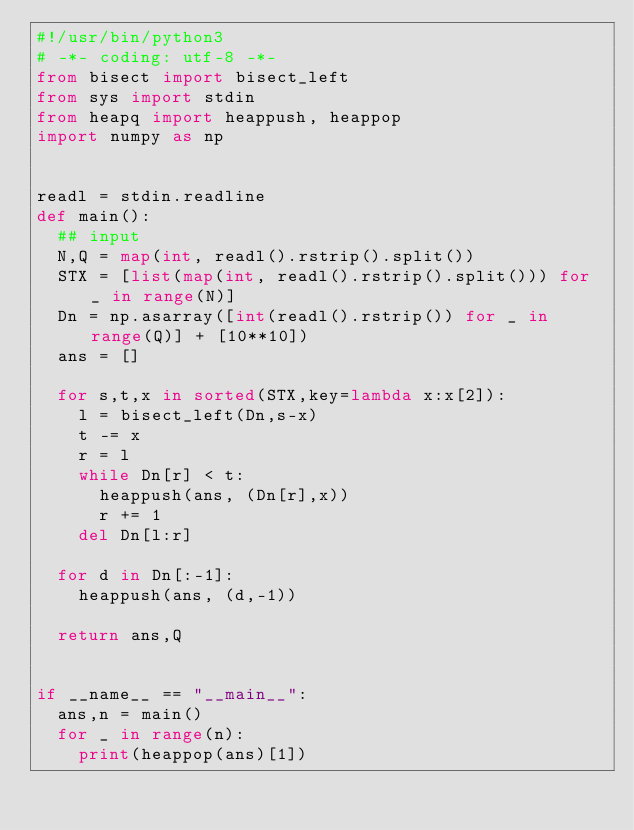Convert code to text. <code><loc_0><loc_0><loc_500><loc_500><_Python_>#!/usr/bin/python3
# -*- coding: utf-8 -*-
from bisect import bisect_left
from sys import stdin
from heapq import heappush, heappop
import numpy as np


readl = stdin.readline
def main():
  ## input
  N,Q = map(int, readl().rstrip().split())
  STX = [list(map(int, readl().rstrip().split())) for _ in range(N)]
  Dn = np.asarray([int(readl().rstrip()) for _ in range(Q)] + [10**10])
  ans = []

  for s,t,x in sorted(STX,key=lambda x:x[2]):
    l = bisect_left(Dn,s-x)
    t -= x
    r = l
    while Dn[r] < t:
      heappush(ans, (Dn[r],x))
      r += 1
    del Dn[l:r]

  for d in Dn[:-1]:
    heappush(ans, (d,-1))

  return ans,Q


if __name__ == "__main__":
  ans,n = main()
  for _ in range(n):
    print(heappop(ans)[1])    
</code> 